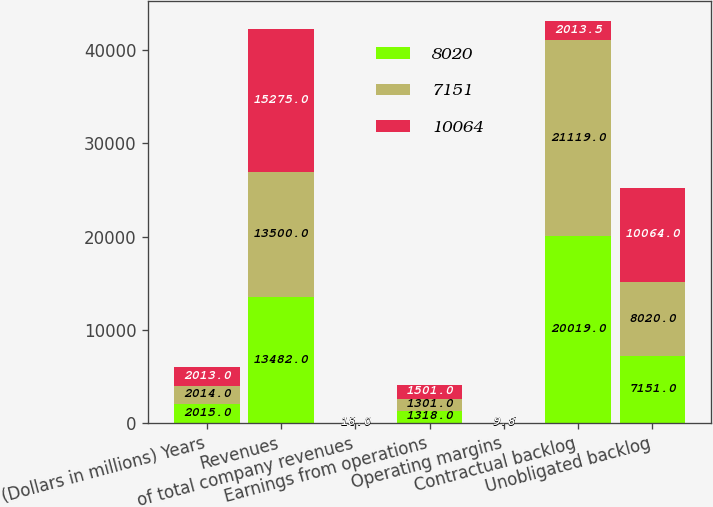<chart> <loc_0><loc_0><loc_500><loc_500><stacked_bar_chart><ecel><fcel>(Dollars in millions) Years<fcel>Revenues<fcel>of total company revenues<fcel>Earnings from operations<fcel>Operating margins<fcel>Contractual backlog<fcel>Unobligated backlog<nl><fcel>8020<fcel>2015<fcel>13482<fcel>14<fcel>1318<fcel>9.8<fcel>20019<fcel>7151<nl><fcel>7151<fcel>2014<fcel>13500<fcel>15<fcel>1301<fcel>9.6<fcel>21119<fcel>8020<nl><fcel>10064<fcel>2013<fcel>15275<fcel>18<fcel>1501<fcel>9.8<fcel>2013.5<fcel>10064<nl></chart> 